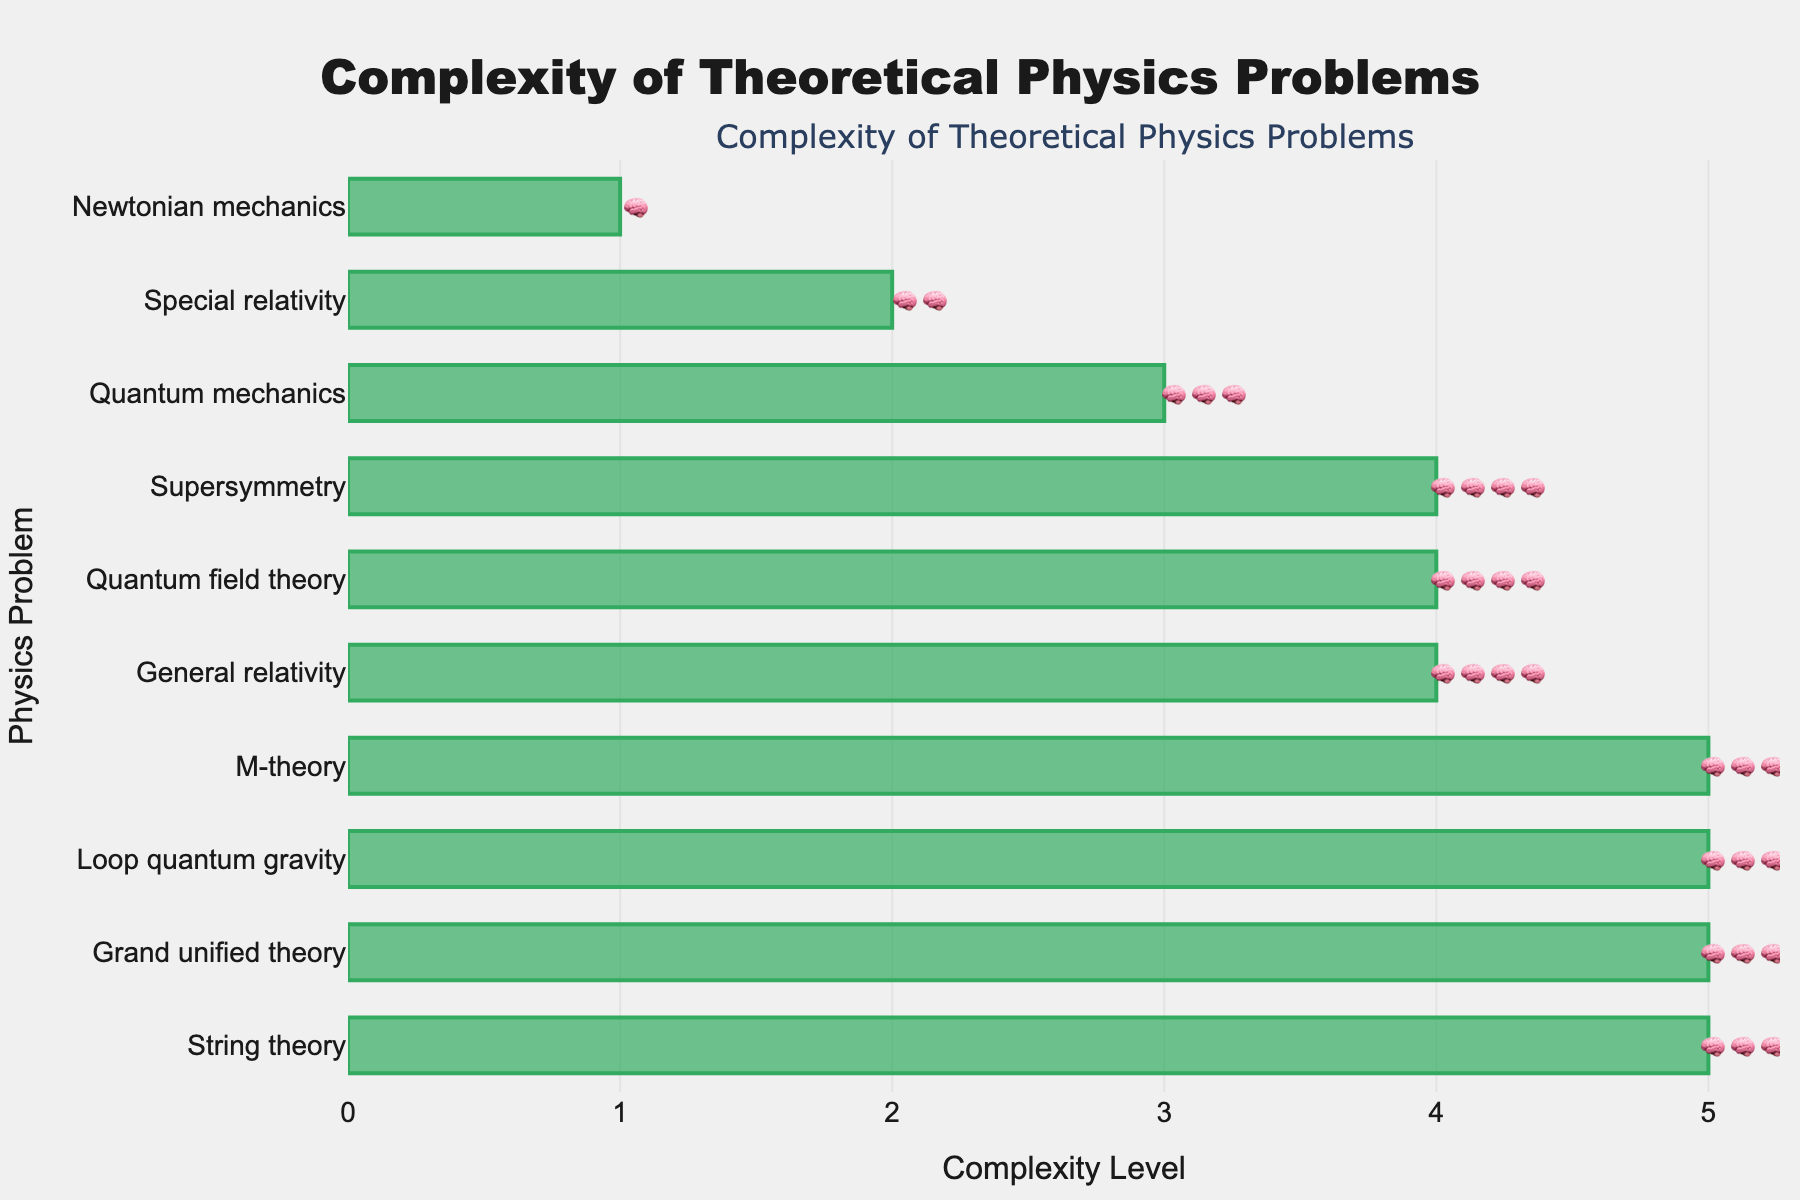What is the least complex problem listed? The problem with the fewest brain emojis represents the least complex problem. In the figure, Newtonian mechanics has the shortest bar and only one brain emoji.
Answer: Newtonian mechanics What is the title of the figure? The title is prominently displayed at the top center of the figure.
Answer: Complexity of Theoretical Physics Problems How many problems have the maximum complexity level? By counting the problems with the maximum number of brain emojis (five), we can determine there are four such problems.
Answer: 4 Which problem is more complex: Special relativity or Quantum mechanics? By comparing the number of brain emojis, Special relativity has two emojis, while Quantum mechanics has three. Thus, Quantum mechanics is more complex.
Answer: Quantum mechanics What is the average complexity level of all the problems combined? Summing each problem's complexity level and then dividing by the number of problems: (1 + 2 + 4 + 3 + 5 + 4 + 5 + 5 + 4 + 5) / 10 = 38 / 10 = 3.8.
Answer: 3.8 Which problem is directly below General relativity in terms of complexity? By locating General relativity with four brain emojis, the problem directly below it in complexity is Quantum field theory, also with four brain emojis.
Answer: Quantum field theory How many problems have a complexity level greater than or equal to four? Counting the number of problems with at least four brain emojis results in six problems.
Answer: 6 Do any problems share the same complexity level as Quantum field theory? Identifying the problems with the same number of brain emojis as Quantum field theory (four) shows that General relativity, Supersymmetry, and Quantum field theory all share the same complexity level.
Answer: Yes How many total brain emojis are present in the figure? Summing all the brain emojis: 1 + 2 + 4 + 3 + 5 + 4 + 5 + 5 + 4 + 5 results in 38 emojis.
Answer: 38 Which problem is less complex: M-theory or Loop quantum gravity? By comparing the number of brain emojis for M-theory (five) and Loop quantum gravity (five), they are equally complex.
Answer: Neither, they are equally complex 